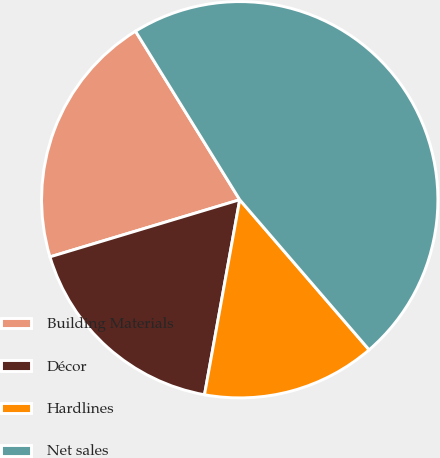Convert chart. <chart><loc_0><loc_0><loc_500><loc_500><pie_chart><fcel>Building Materials<fcel>Décor<fcel>Hardlines<fcel>Net sales<nl><fcel>20.84%<fcel>17.5%<fcel>14.17%<fcel>47.49%<nl></chart> 